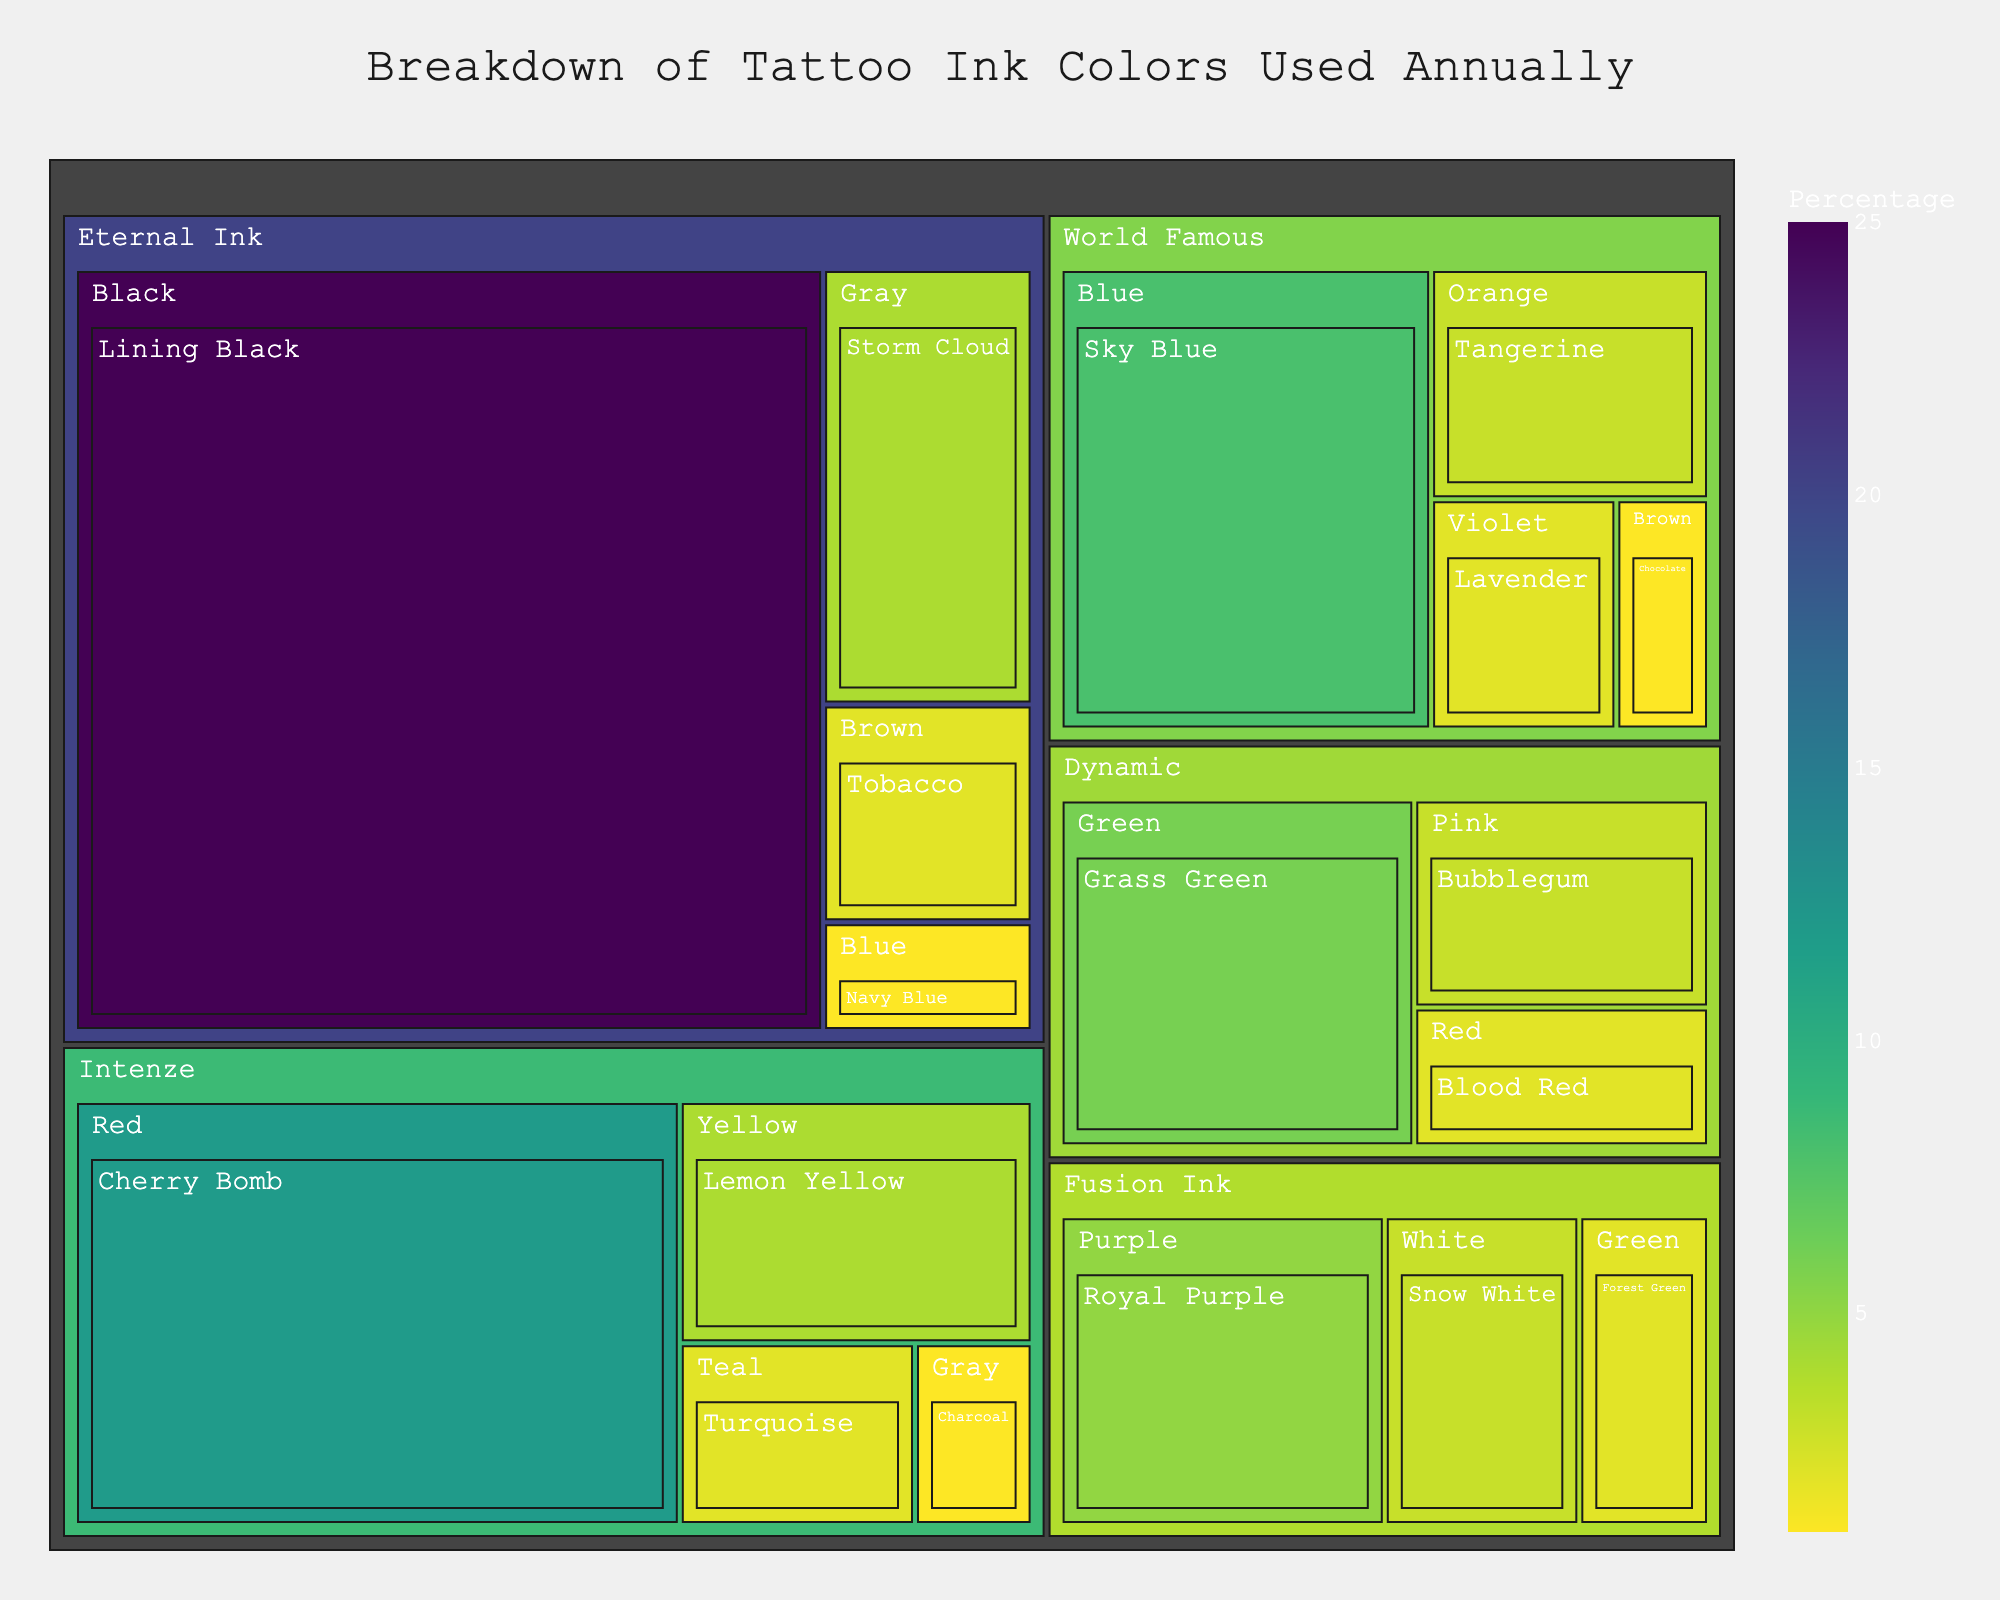Is there a specific brand that uses the highest percentage of ink? The percentage is shown for each color and brand. The largest section in the treemap is Eternal Ink - Black - Lining Black, which is 25%.
Answer: Eternal Ink Which color shade holds the highest percentage of tattoo ink usage? To determine the shade with the highest percentage, look at the largest section in the treemap. The largest section is Lining Black from Eternal Ink with 25%.
Answer: Lining Black How many different brands are represented in the treemap? The treemap has various sections organized by brand. Looking at the top-level sections, there are five distinct brands: Eternal Ink, Intenze, World Famous, Dynamic, and Fusion Ink.
Answer: 5 If you combine the percentages of all green shades, what is the total? There are two green sections: Grass Green (6%) from Dynamic and Forest Green (2%) from Fusion Ink. Summing these up: 6% + 2% = 8%.
Answer: 8% Which brand has the most variety in ink colors (number of unique colors)? Count the unique colors under each brand in the treemap. Eternal Ink has the most variety with 4 colors: Black, Gray, Brown, and Blue.
Answer: Eternal Ink Is the percentage of Red shades from Dynamic higher or lower than Cherry Bomb Red from Intenze? Dynamic has Red - Blood Red at 2%, and Intenze has Red - Cherry Bomb at 12%. Comparing these percentages, Cherry Bomb is higher.
Answer: Lower What is the combined percentage of the two least used shades? Look for the smallest sections in the treemap. Navy Blue from Eternal Ink and Charcoal from Intenze each have 1%, so the combined percentage is 1% + 1% = 2%.
Answer: 2% Which color appears most frequently across all brands? Count each occurrence of the colors in the treemap. Red appears thrice (Cherry Bomb, Blood Red, and another brand), making it the most frequent.
Answer: Red How many unique shades are included in the figure? Each section in the treemap represents a unique shade. Counting all unique shades in the figure, we find there are 18 shades.
Answer: 18 Is there a color that is present in all brands? Observe the colors used by each brand. Not all colors are present in all brands; for example, only specific shades of red appear in different brands, but not all colors are used by all brands.
Answer: No 